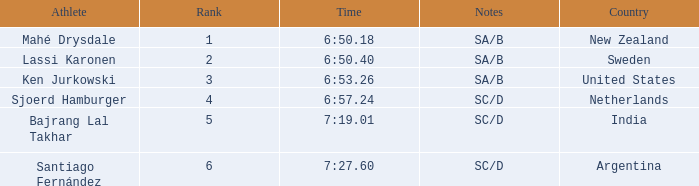What is the highest rank for the team that raced a time of 6:50.40? 2.0. 